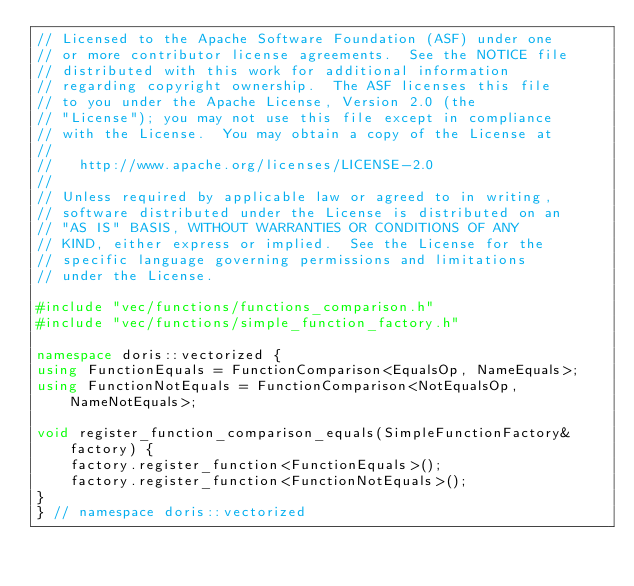<code> <loc_0><loc_0><loc_500><loc_500><_C++_>// Licensed to the Apache Software Foundation (ASF) under one
// or more contributor license agreements.  See the NOTICE file
// distributed with this work for additional information
// regarding copyright ownership.  The ASF licenses this file
// to you under the Apache License, Version 2.0 (the
// "License"); you may not use this file except in compliance
// with the License.  You may obtain a copy of the License at
//
//   http://www.apache.org/licenses/LICENSE-2.0
//
// Unless required by applicable law or agreed to in writing,
// software distributed under the License is distributed on an
// "AS IS" BASIS, WITHOUT WARRANTIES OR CONDITIONS OF ANY
// KIND, either express or implied.  See the License for the
// specific language governing permissions and limitations
// under the License.

#include "vec/functions/functions_comparison.h"
#include "vec/functions/simple_function_factory.h"

namespace doris::vectorized {
using FunctionEquals = FunctionComparison<EqualsOp, NameEquals>;
using FunctionNotEquals = FunctionComparison<NotEqualsOp, NameNotEquals>;

void register_function_comparison_equals(SimpleFunctionFactory& factory) {
    factory.register_function<FunctionEquals>();
    factory.register_function<FunctionNotEquals>();
}
} // namespace doris::vectorized
</code> 